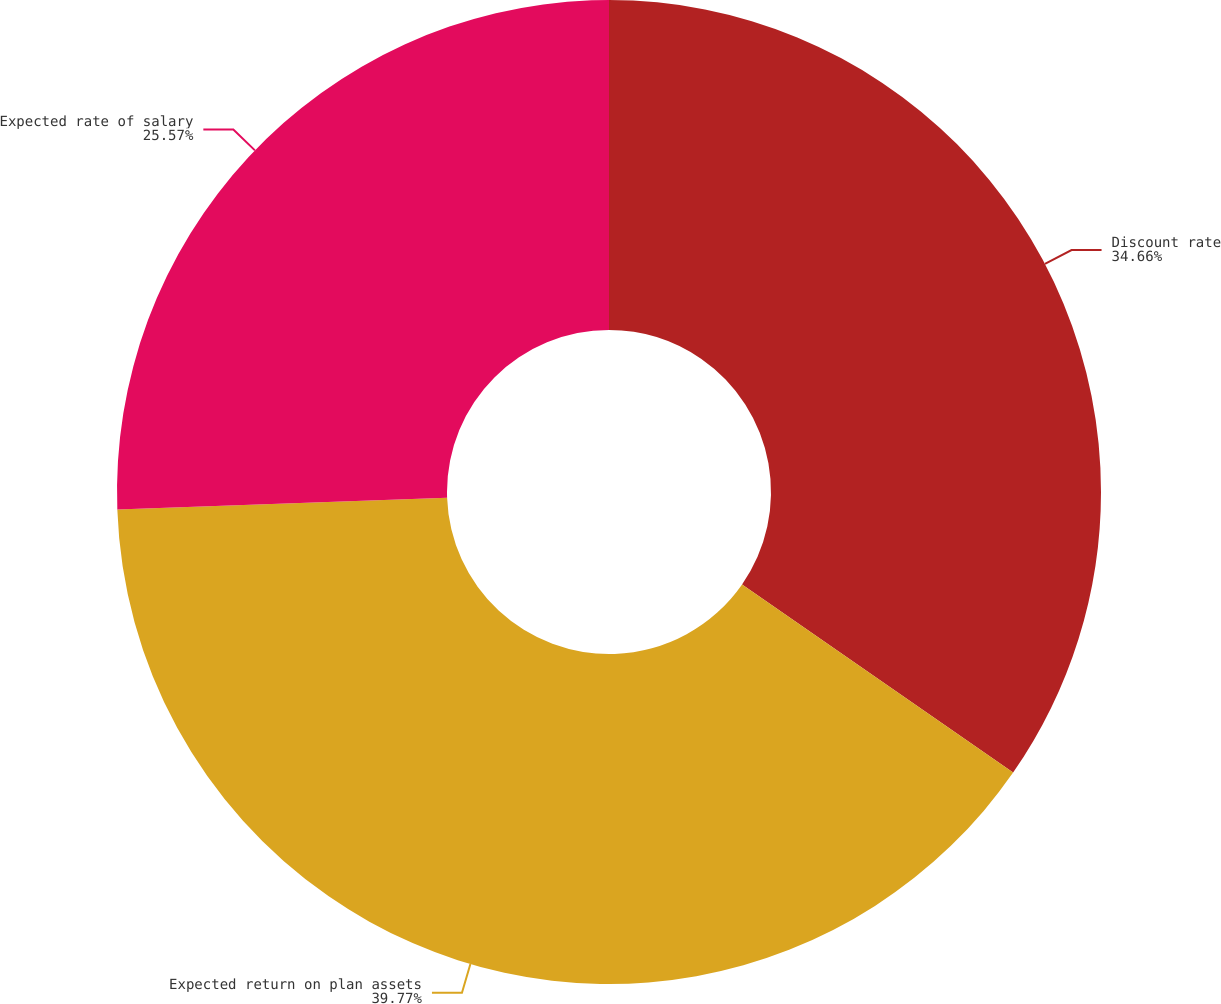Convert chart to OTSL. <chart><loc_0><loc_0><loc_500><loc_500><pie_chart><fcel>Discount rate<fcel>Expected return on plan assets<fcel>Expected rate of salary<nl><fcel>34.66%<fcel>39.77%<fcel>25.57%<nl></chart> 